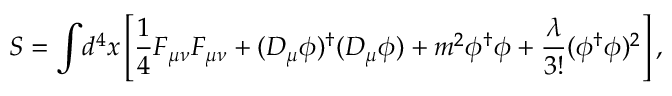<formula> <loc_0><loc_0><loc_500><loc_500>S = { \int } d ^ { 4 } x \left [ \frac { 1 } { 4 } F _ { \mu \nu } F _ { \mu \nu } + ( D _ { \mu } \phi ) ^ { \dag } ( D _ { \mu } \phi ) + m ^ { 2 } \phi ^ { \dag } \phi + \frac { \lambda } { 3 ! } ( \phi ^ { \dag } \phi ) ^ { 2 } \right ] ,</formula> 